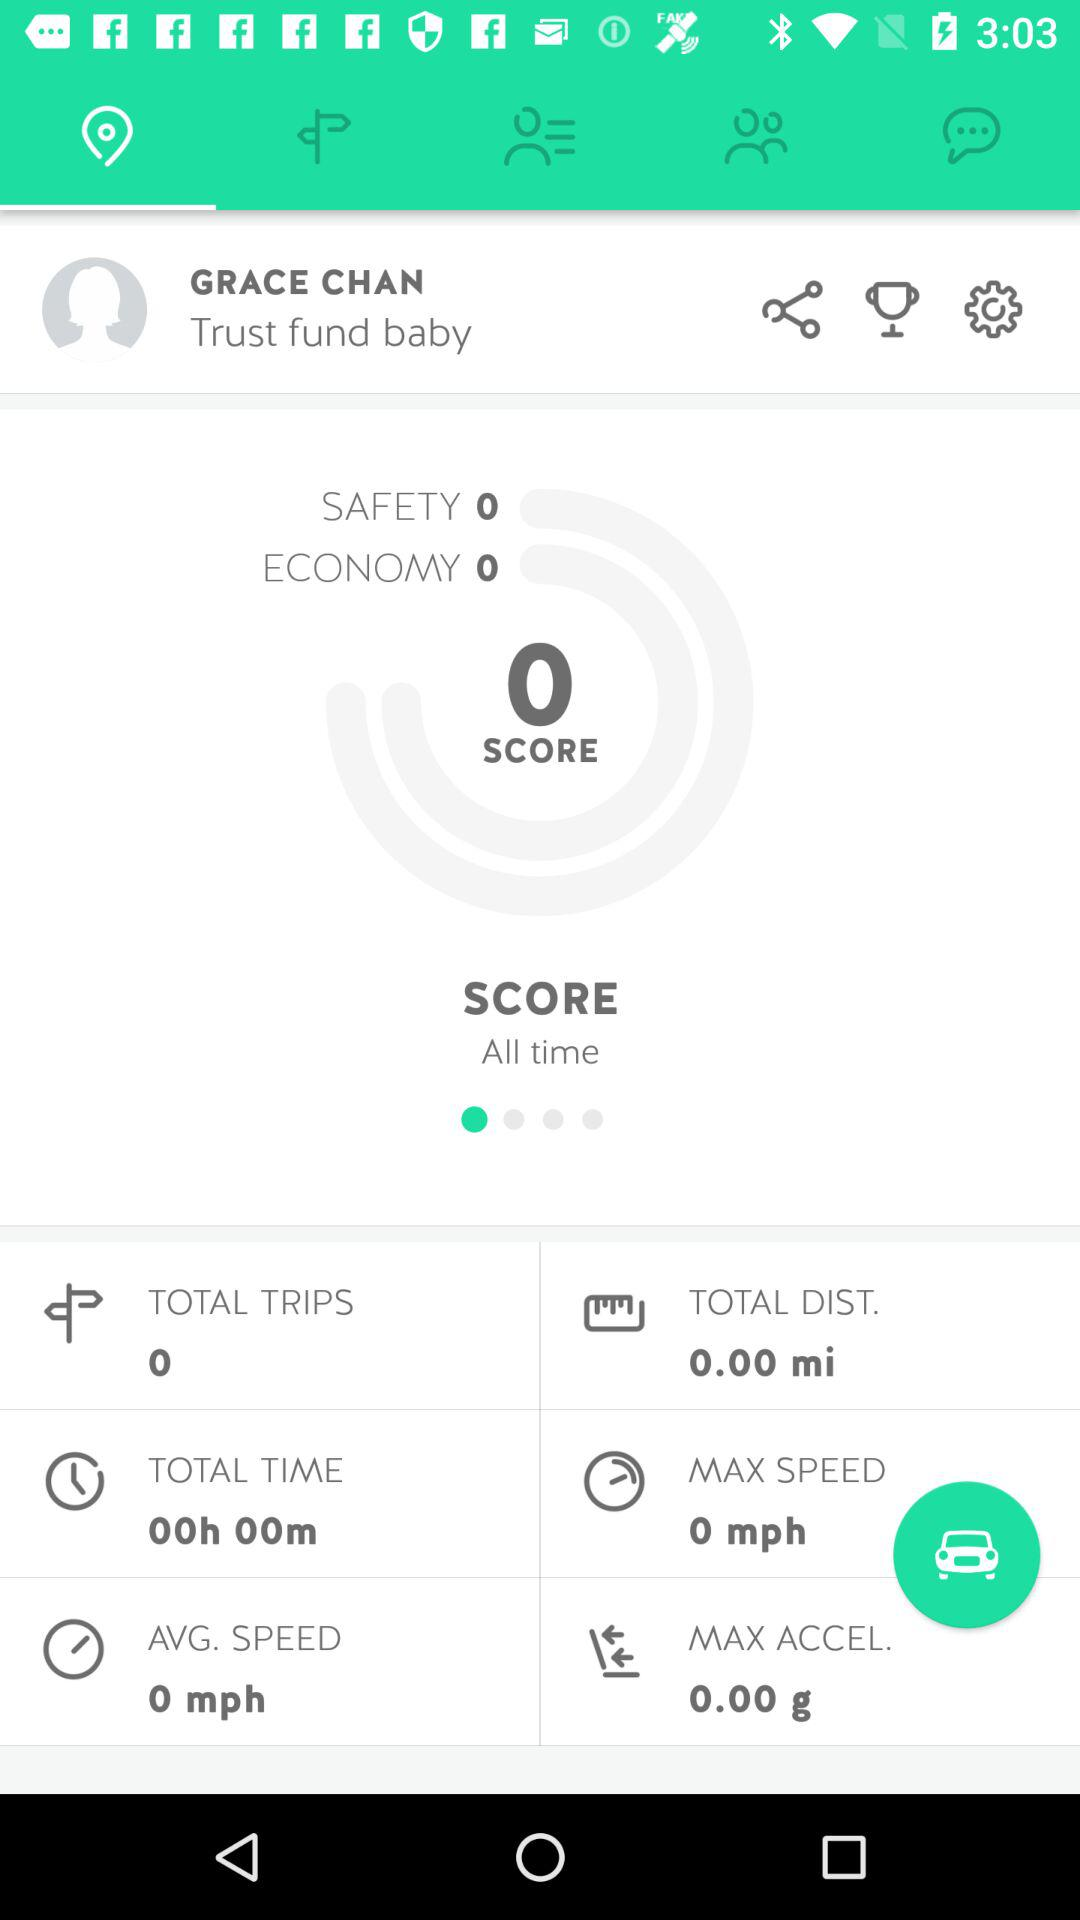What is the total number of miles Grace Chan has driven?
Answer the question using a single word or phrase. 0.00 mi 